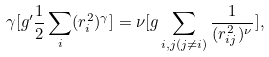<formula> <loc_0><loc_0><loc_500><loc_500>\gamma [ g ^ { \prime } \frac { 1 } { 2 } \sum _ { i } ( r _ { i } ^ { 2 } ) ^ { \gamma } ] = \nu [ g \sum _ { i , j ( j \ne i ) } \frac { 1 } { ( r _ { i j } ^ { 2 } ) ^ { \nu } } ] ,</formula> 